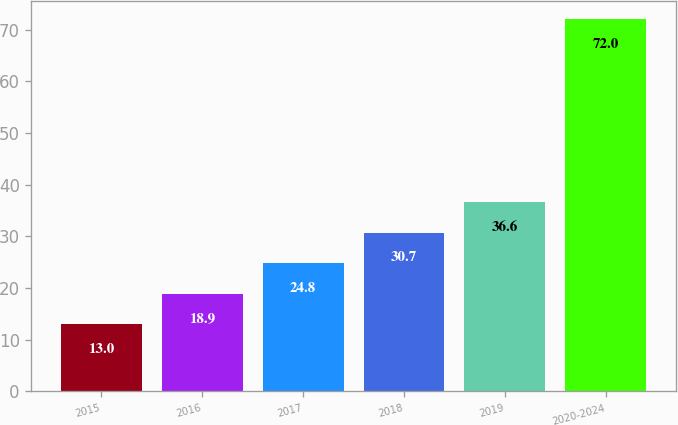<chart> <loc_0><loc_0><loc_500><loc_500><bar_chart><fcel>2015<fcel>2016<fcel>2017<fcel>2018<fcel>2019<fcel>2020-2024<nl><fcel>13<fcel>18.9<fcel>24.8<fcel>30.7<fcel>36.6<fcel>72<nl></chart> 